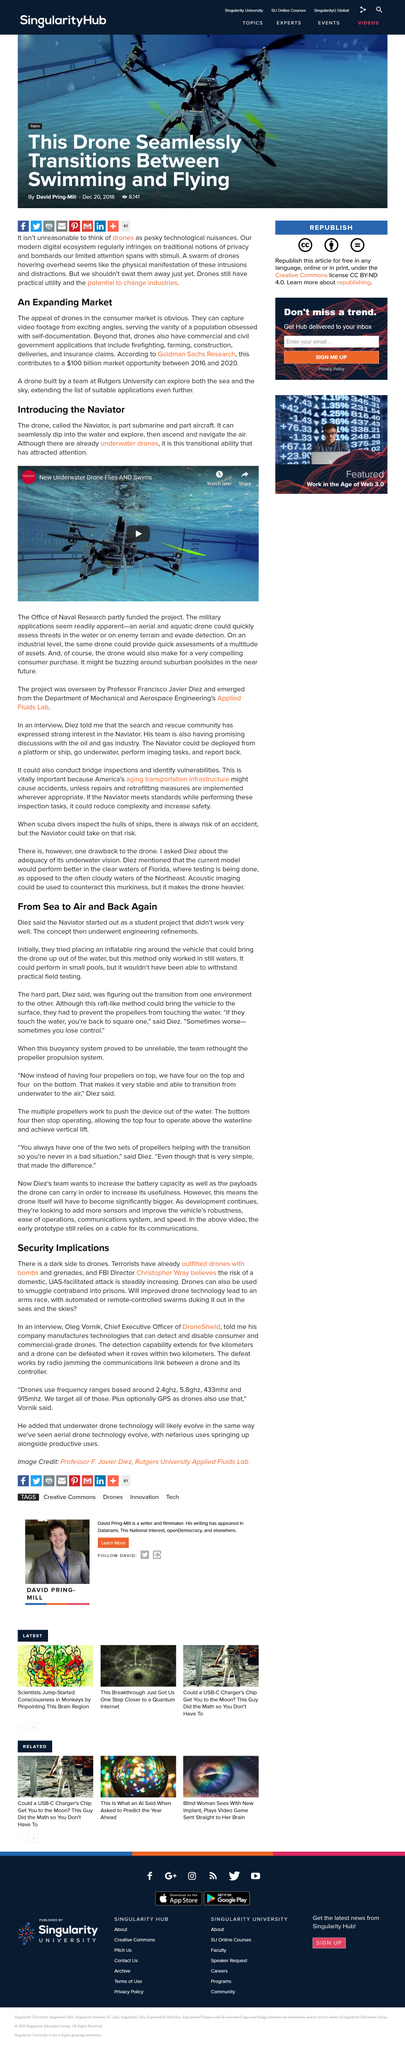Identify some key points in this picture. The name of the existing underwater drone depicted in the image is [Underwater Drone]. Yes, drones can be used for both firefighting and sea exploration. The Chief Executive Officer of DroneShield is named Oleg. The market opportunity for drones between 2016 and 2020 is projected to reach a dollar value of $100 billion. Rutgers University's team has developed a drone that is capable of exploring both the sea and the sky. 